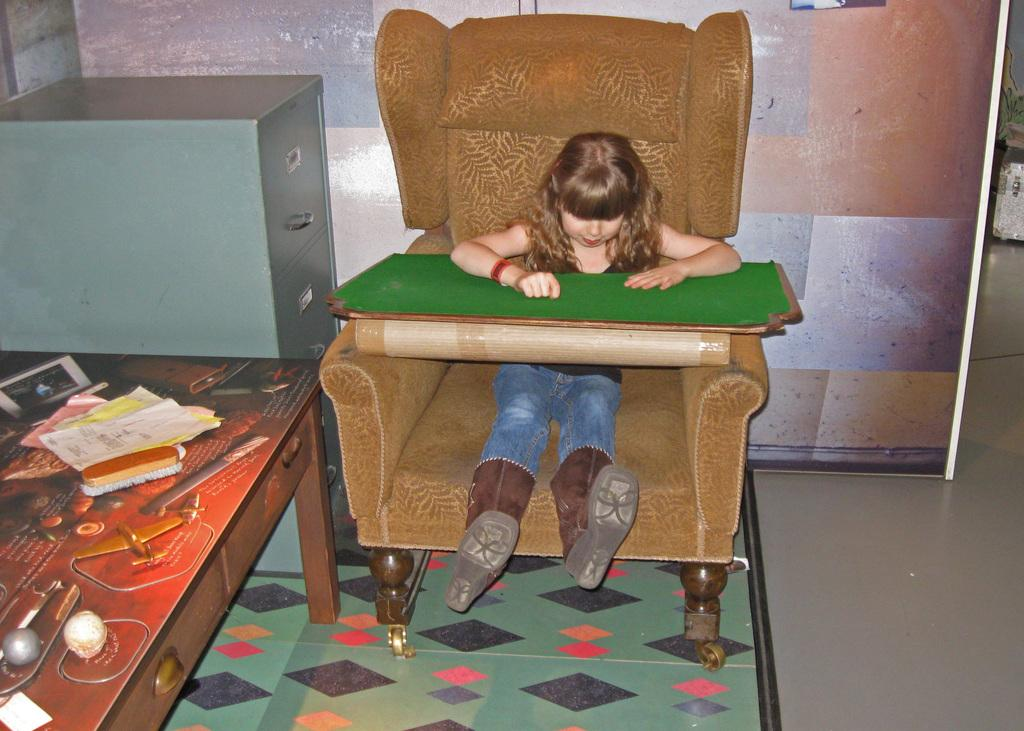What is the girl doing in the image? The girl is sitting on a couch in the image. What is in front of the girl? There is a green color board in front of the girl. Are there any furniture pieces visible in the image? Yes, there is a cupboard in the image. What is on the table in the image? There is a brush and papers on the table in the image. How would you describe the wall in the image? The wall is colorful in the image. What type of coal is being used by the babies in the image? There are no babies or coal present in the image. Is there a glove visible on the girl's hand in the image? No, there is no glove visible on the girl's hand in the image. 